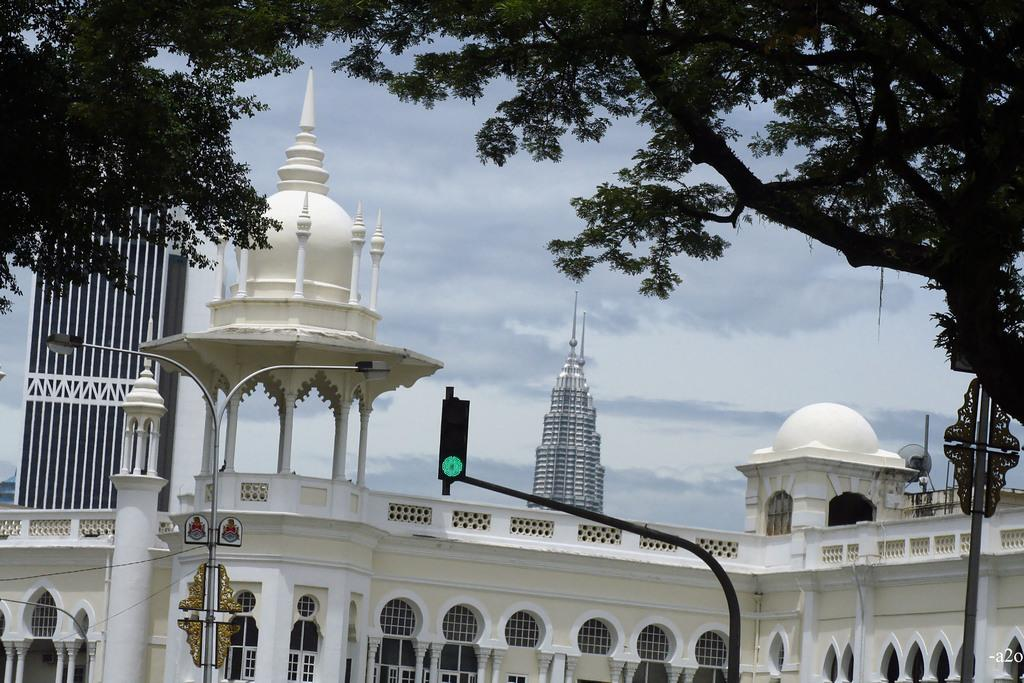What type of structure is visible in the image? There is a building in the image. What architectural features can be seen on the building? The building has windows and pillars. What other objects are present in the image? There are poles, lights, signal lights, and a tree in the image. What is visible in the sky? The sky is visible in the image, and clouds are present. What type of honey is being harvested from the tree in the image? There is no honey or tree with honey in the image; it features a building, poles, lights, signal lights, and a tree without any indication of honey. Can you see a boot hanging from the signal lights in the image? There is no boot present in the image; it only features a building, poles, lights, signal lights, and a tree. 